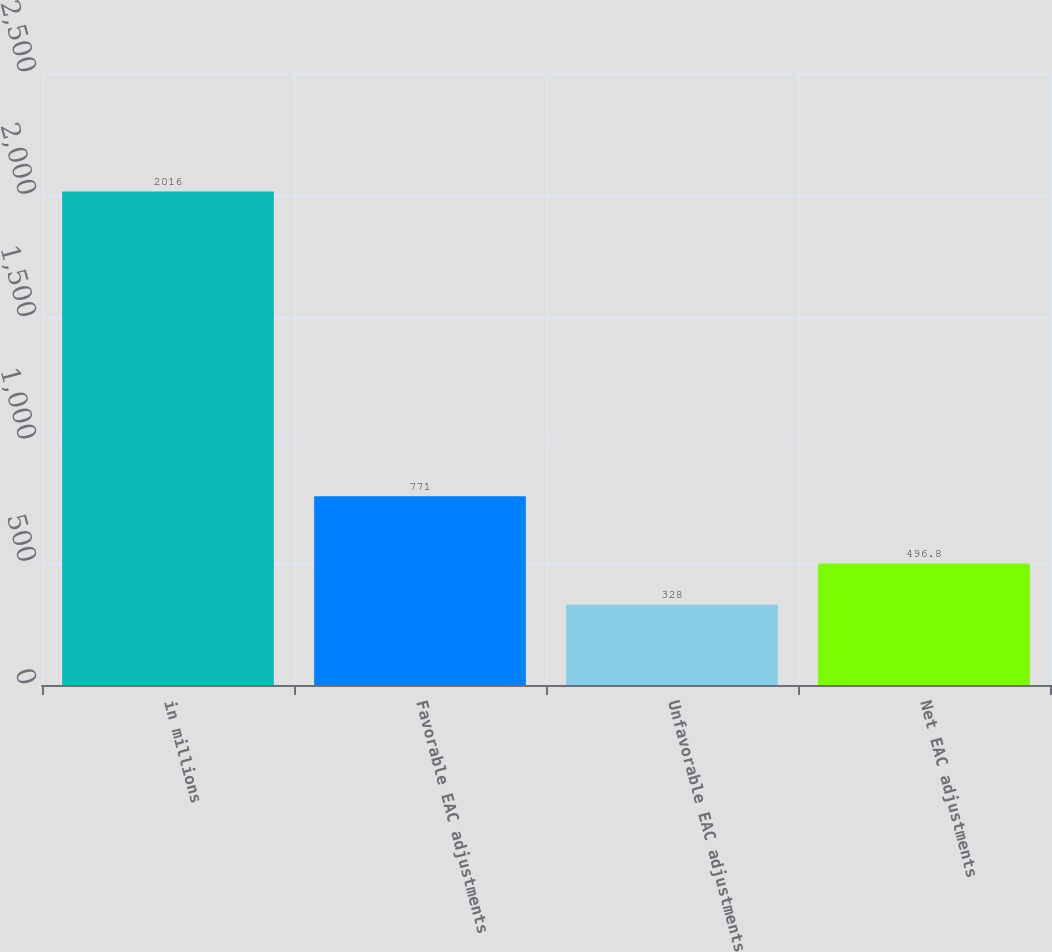<chart> <loc_0><loc_0><loc_500><loc_500><bar_chart><fcel>in millions<fcel>Favorable EAC adjustments<fcel>Unfavorable EAC adjustments<fcel>Net EAC adjustments<nl><fcel>2016<fcel>771<fcel>328<fcel>496.8<nl></chart> 